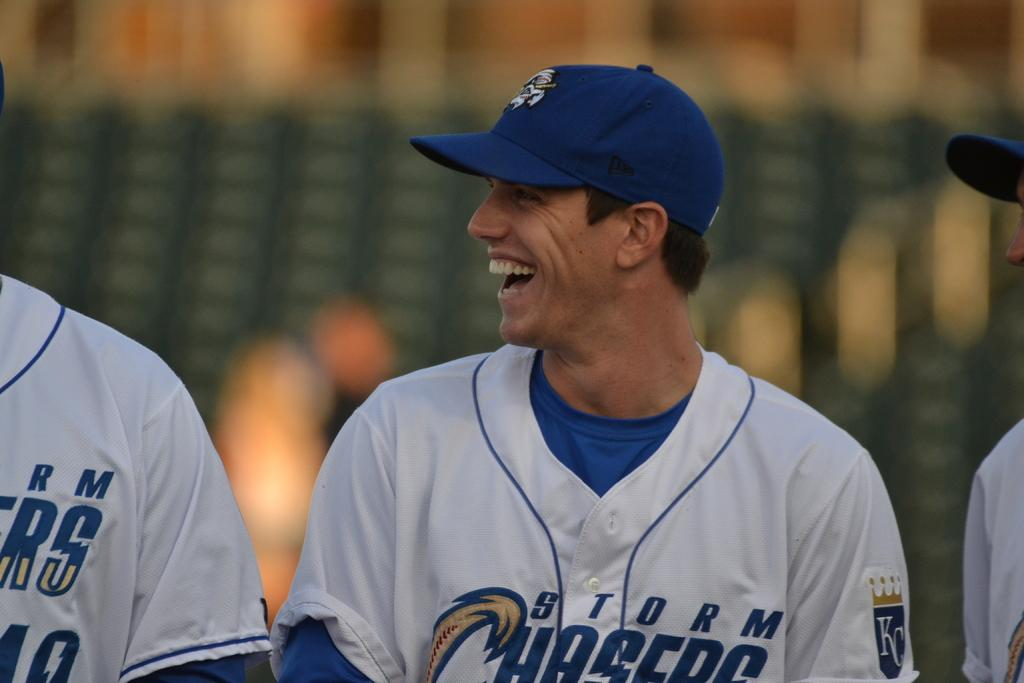<image>
Describe the image concisely. Storm Chasers baseball player with Kansas City logo smiling. 